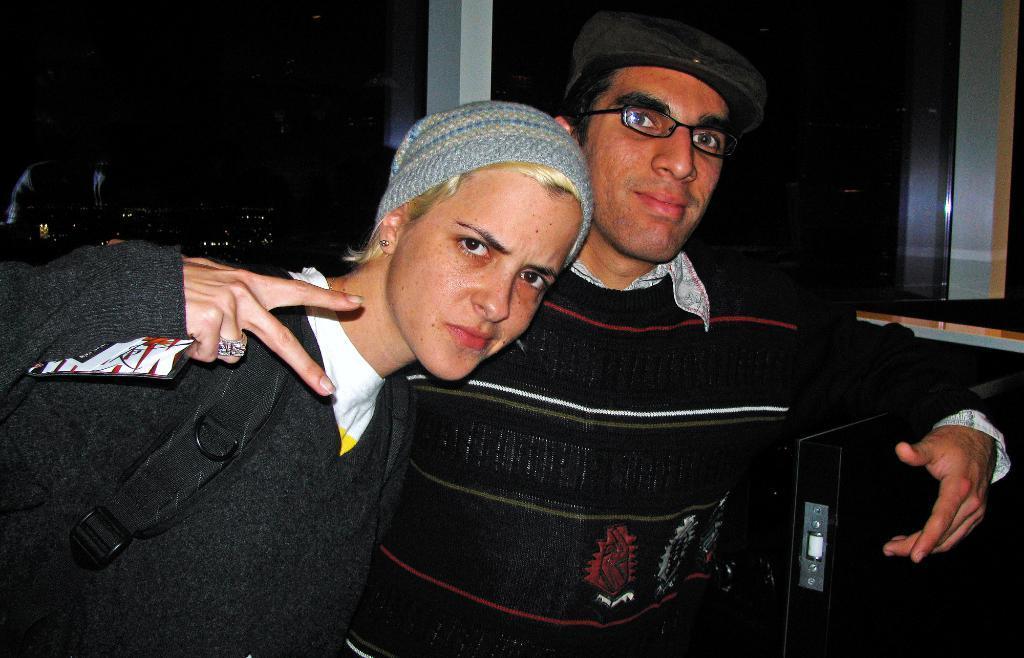In one or two sentences, can you explain what this image depicts? In this image, we can see two persons in front of the glass window. There is an object in the bottom right of the image. 